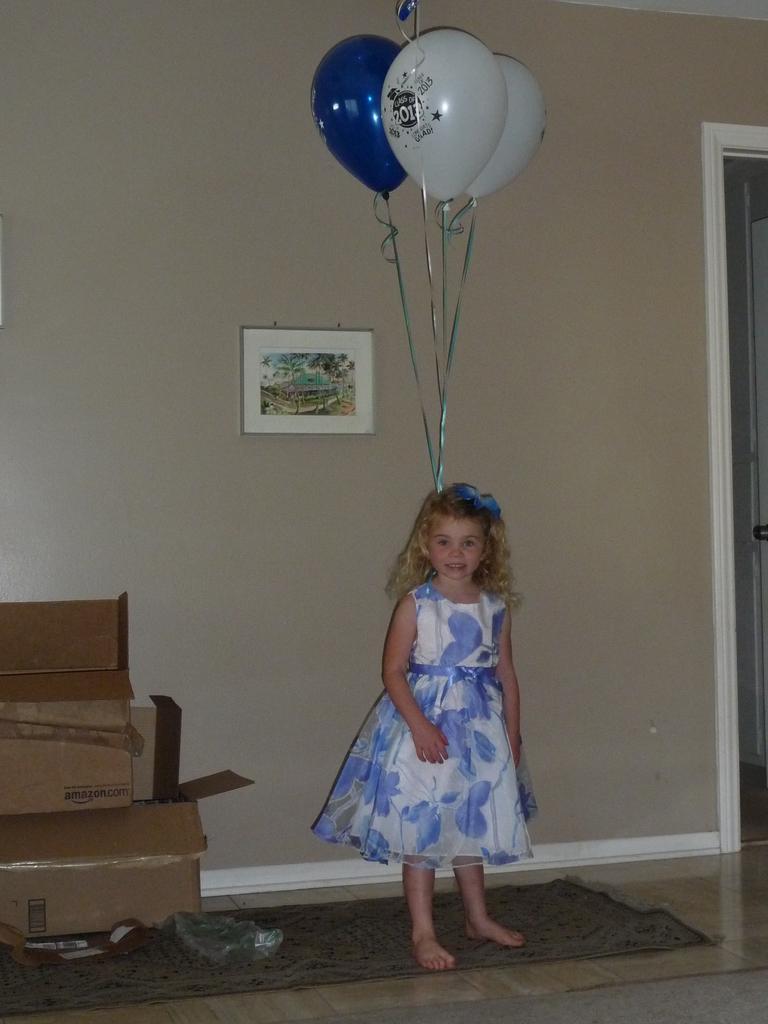Describe this image in one or two sentences. In this image we can see a kid wearing blue and white color dress also wearing headband which is of blue color to which some balloons are tied and in the background of the image there are some cardboard boxes, a wall to which painting is attached and on right side of the image there is a door. 